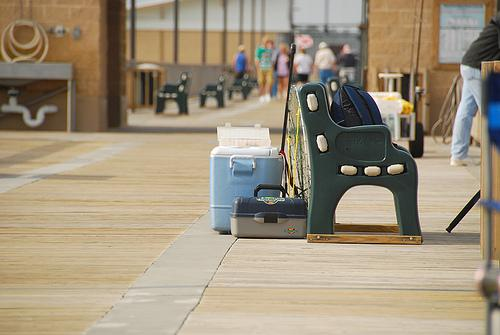Question: when was this taken?
Choices:
A. During the day.
B. Early morning.
C. Dinner time.
D. 1:42pm.
Answer with the letter. Answer: A Question: who is in the background?
Choices:
A. A babysitter.
B. Parents.
C. A crowd.
D. A group of people.
Answer with the letter. Answer: D Question: what color is the bench?
Choices:
A. Blue.
B. Green.
C. White.
D. Black.
Answer with the letter. Answer: B Question: why is there a bench?
Choices:
A. For the park.
B. For people fishing to sit on.
C. For people to rest.
D. For shoppers to take a break.
Answer with the letter. Answer: B Question: where was this taken?
Choices:
A. In a living room.
B. In a parking lot.
C. Outside on a fishing dock.
D. By the beach.
Answer with the letter. Answer: C 